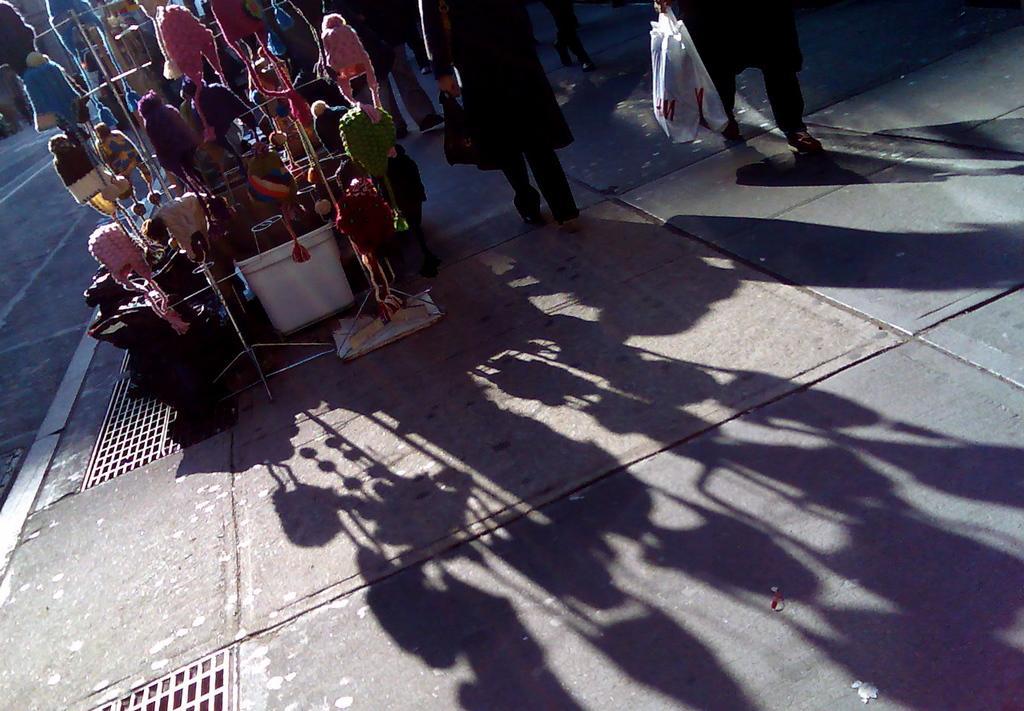Please provide a concise description of this image. In the image there is a monkey cap stall and beside the stall some people are walking on the footpath and the shadow of the stalls and the people are being reflected on the ground. 